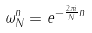<formula> <loc_0><loc_0><loc_500><loc_500>\omega _ { N } ^ { n } = e ^ { - \frac { 2 \pi i } { N } n }</formula> 